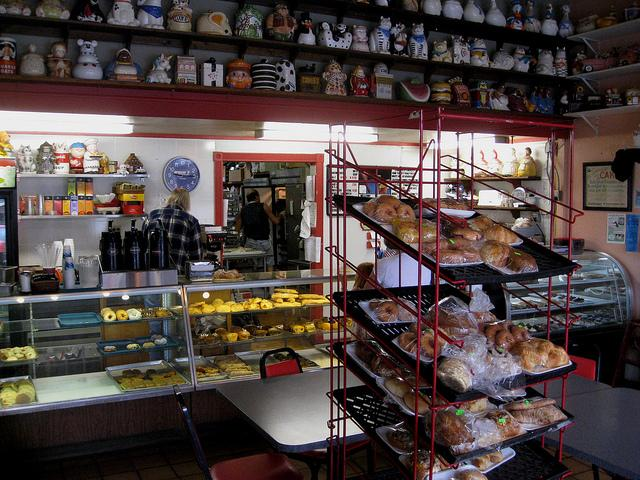What type of items are on the rack in front? Please explain your reasoning. day old. That is some old bread at the front. 